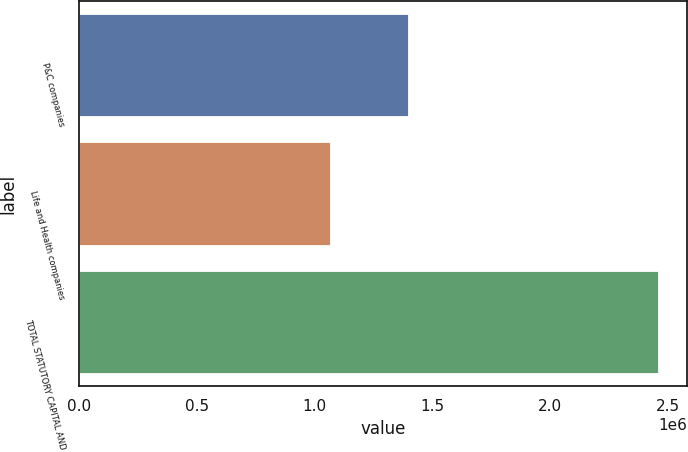<chart> <loc_0><loc_0><loc_500><loc_500><bar_chart><fcel>P&C companies<fcel>Life and Health companies<fcel>TOTAL STATUTORY CAPITAL AND<nl><fcel>1.3963e+06<fcel>1.06417e+06<fcel>2.46048e+06<nl></chart> 